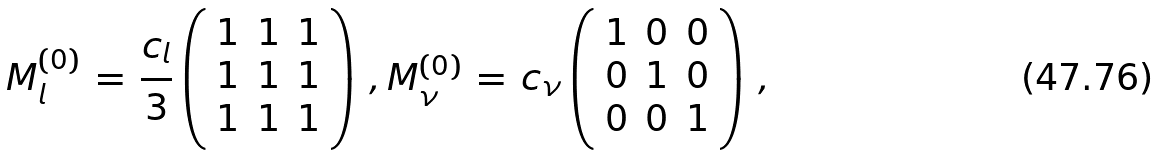<formula> <loc_0><loc_0><loc_500><loc_500>M _ { l } ^ { ( 0 ) } \, = \, \frac { c _ { l } } { 3 } \left ( \begin{array} { l l l } { 1 } & { 1 } & { 1 } \\ { 1 } & { 1 } & { 1 } \\ { 1 } & { 1 } & { 1 } \end{array} \right ) \, , M _ { \nu } ^ { ( 0 ) } \, = \, c _ { \nu } \left ( \begin{array} { l l l } { 1 } & { 0 } & { 0 } \\ { 0 } & { 1 } & { 0 } \\ { 0 } & { 0 } & { 1 } \end{array} \right ) \, ,</formula> 